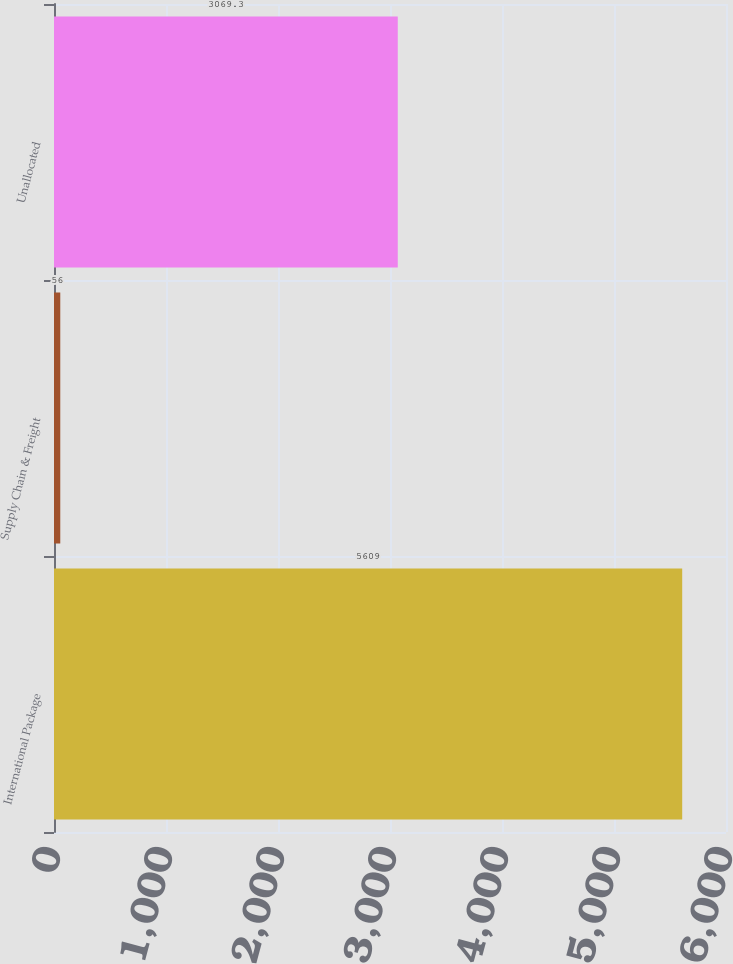Convert chart. <chart><loc_0><loc_0><loc_500><loc_500><bar_chart><fcel>International Package<fcel>Supply Chain & Freight<fcel>Unallocated<nl><fcel>5609<fcel>56<fcel>3069.3<nl></chart> 